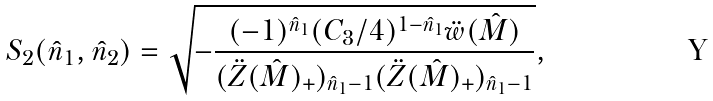Convert formula to latex. <formula><loc_0><loc_0><loc_500><loc_500>S _ { 2 } ( \hat { n } _ { 1 } , \hat { n } _ { 2 } ) = \sqrt { - \frac { ( - 1 ) ^ { \hat { n } _ { 1 } } ( C _ { 3 } / 4 ) ^ { 1 - \hat { n } _ { 1 } } \ddot { w } ( \hat { M } ) } { ( \ddot { Z } ( \hat { M } ) _ { + } ) _ { \hat { n } _ { 1 } - 1 } ( \ddot { Z } ( \hat { M } ) _ { + } ) _ { \hat { n } _ { 1 } - 1 } } } ,</formula> 